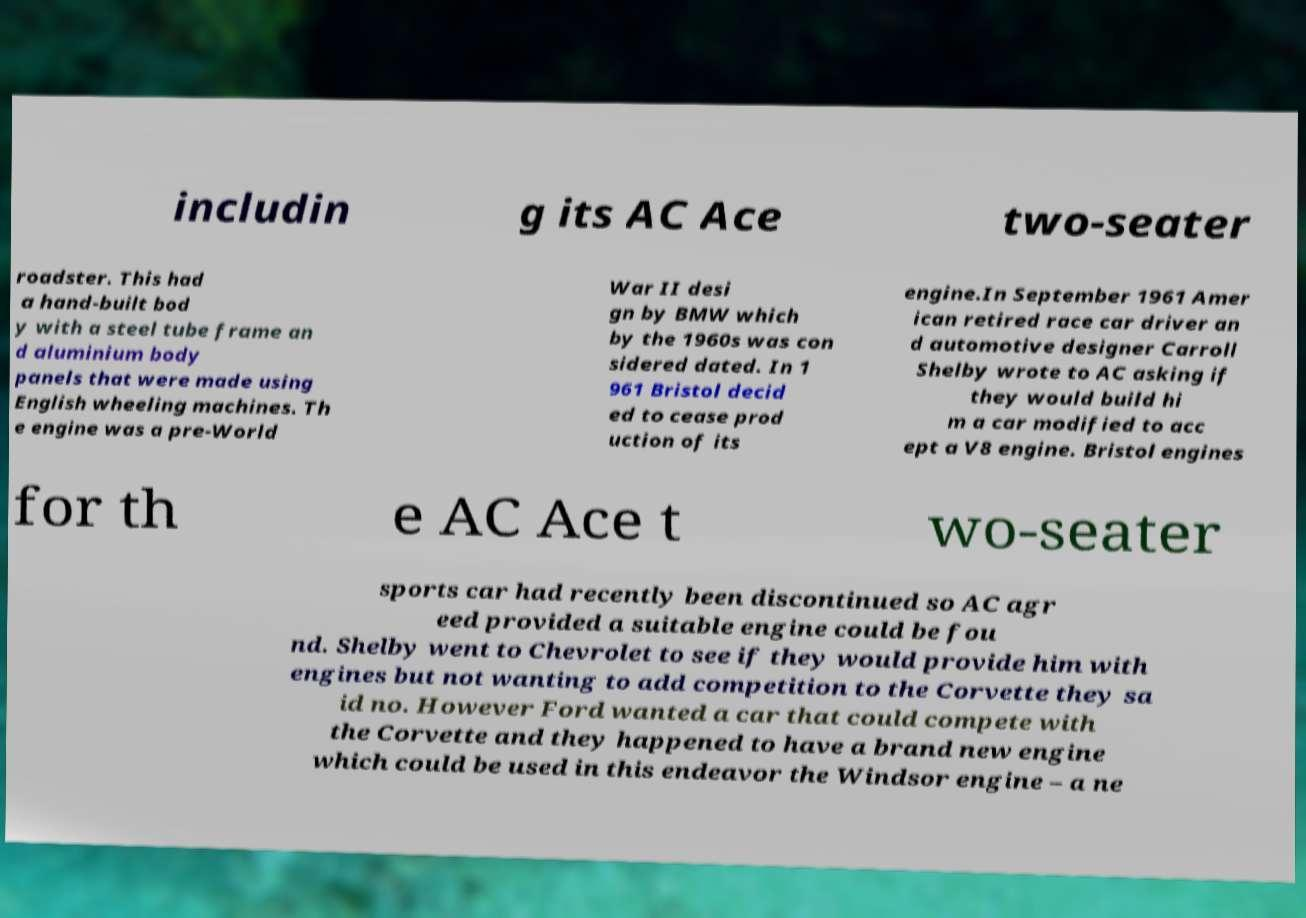Please identify and transcribe the text found in this image. includin g its AC Ace two-seater roadster. This had a hand-built bod y with a steel tube frame an d aluminium body panels that were made using English wheeling machines. Th e engine was a pre-World War II desi gn by BMW which by the 1960s was con sidered dated. In 1 961 Bristol decid ed to cease prod uction of its engine.In September 1961 Amer ican retired race car driver an d automotive designer Carroll Shelby wrote to AC asking if they would build hi m a car modified to acc ept a V8 engine. Bristol engines for th e AC Ace t wo-seater sports car had recently been discontinued so AC agr eed provided a suitable engine could be fou nd. Shelby went to Chevrolet to see if they would provide him with engines but not wanting to add competition to the Corvette they sa id no. However Ford wanted a car that could compete with the Corvette and they happened to have a brand new engine which could be used in this endeavor the Windsor engine – a ne 